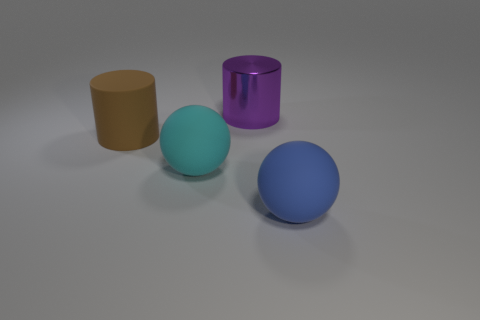Add 4 small objects. How many objects exist? 8 Subtract 1 balls. How many balls are left? 1 Subtract all purple cylinders. How many cylinders are left? 1 Subtract all blue cylinders. How many red spheres are left? 0 Subtract all tiny gray shiny cylinders. Subtract all large blue rubber objects. How many objects are left? 3 Add 2 blue objects. How many blue objects are left? 3 Add 4 purple shiny cylinders. How many purple shiny cylinders exist? 5 Subtract 0 yellow balls. How many objects are left? 4 Subtract all yellow cylinders. Subtract all blue blocks. How many cylinders are left? 2 